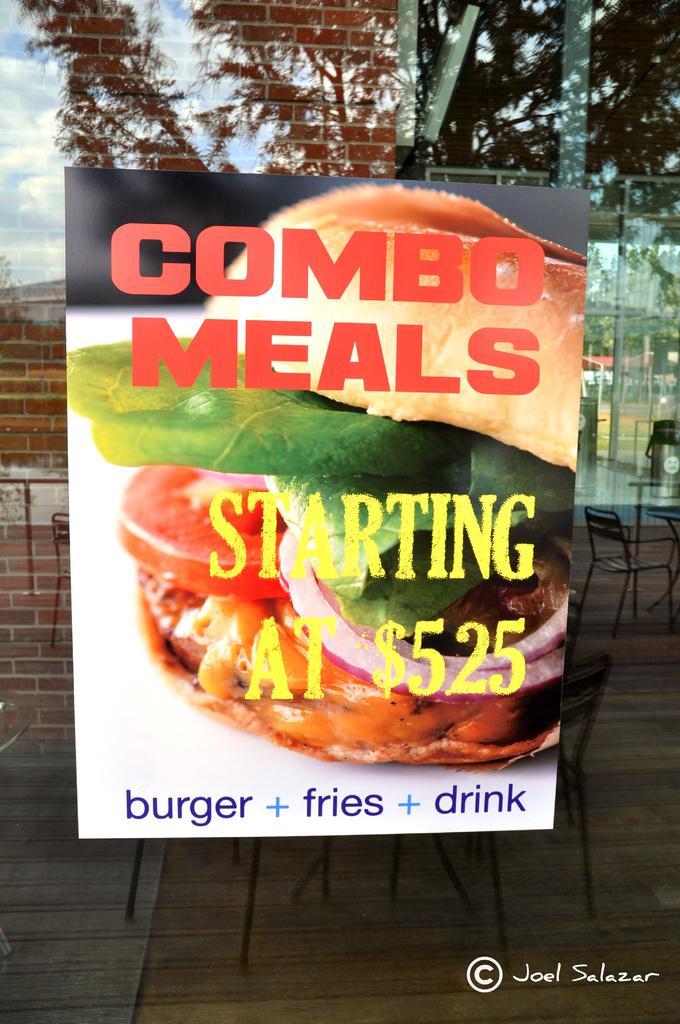Describe this image in one or two sentences. In the center of the picture there is a poster attached to a glass window, outside the window there are chairs, tables. On the left there is a brick wall. On the right there are poles, trees and buildings which can be seen through the reflection in the glass mirror. 